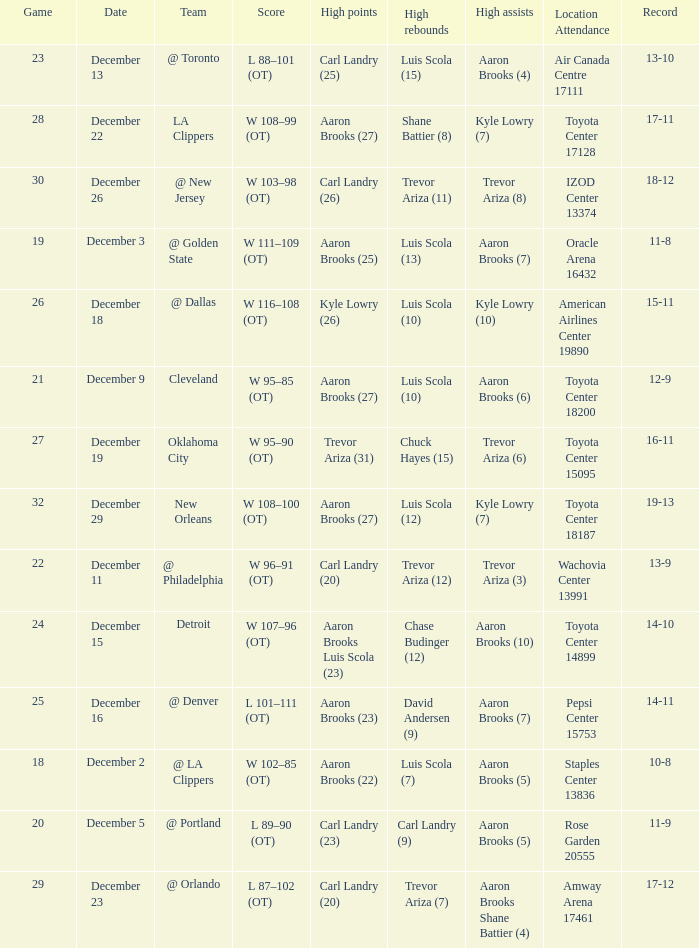What's the end score of the game where Shane Battier (8) did the high rebounds? W 108–99 (OT). 